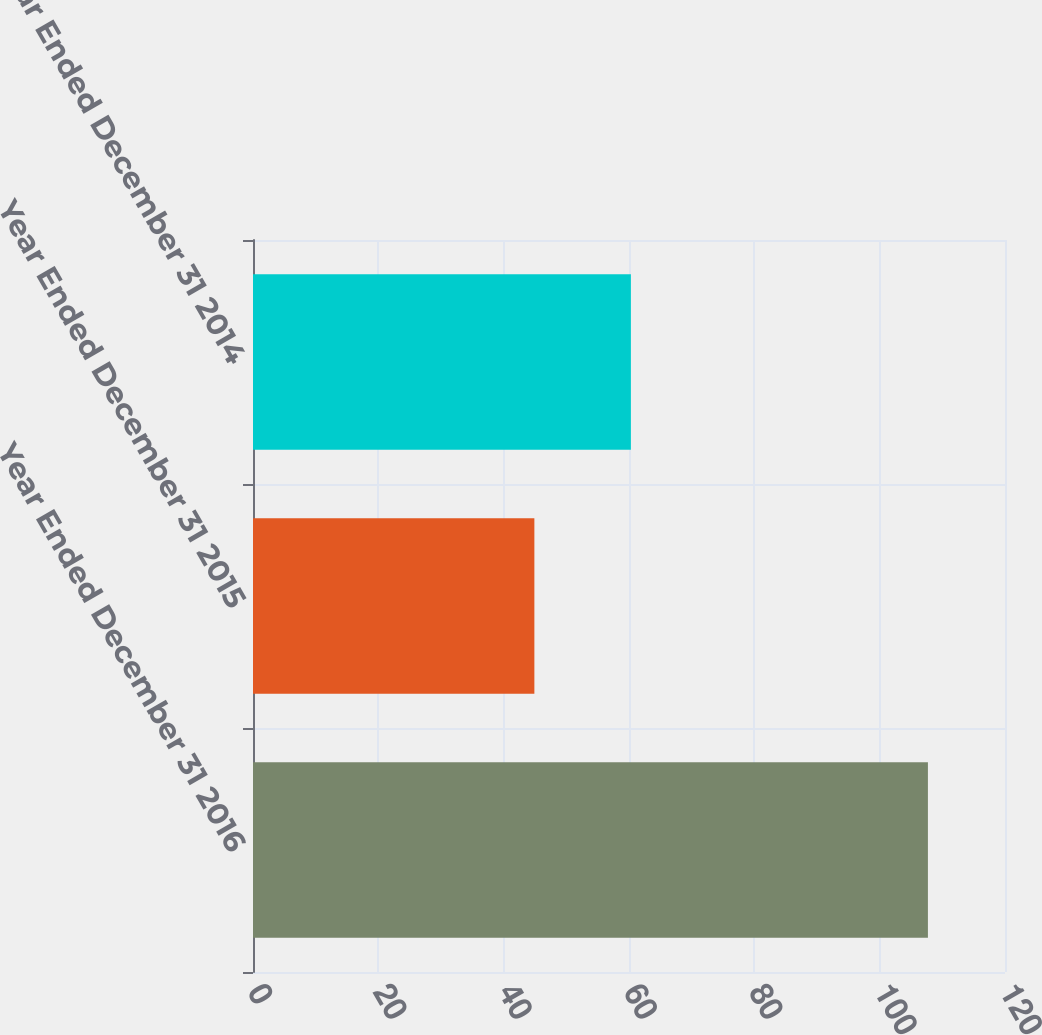Convert chart. <chart><loc_0><loc_0><loc_500><loc_500><bar_chart><fcel>Year Ended December 31 2016<fcel>Year Ended December 31 2015<fcel>Year Ended December 31 2014<nl><fcel>107.7<fcel>44.9<fcel>60.3<nl></chart> 